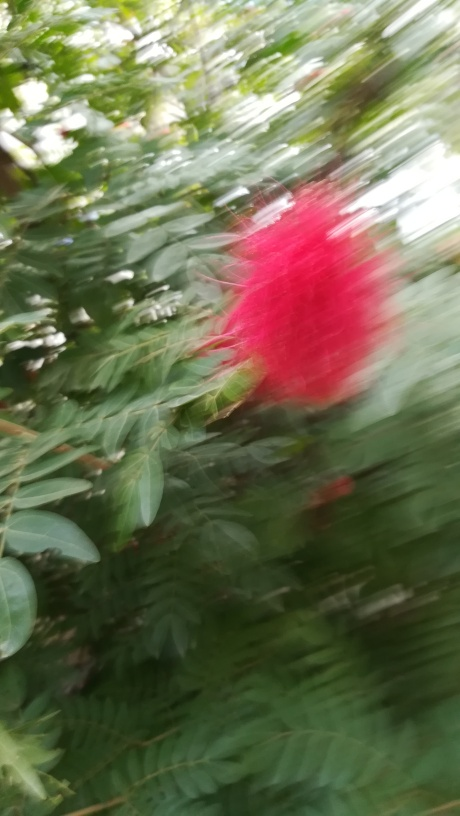What is the main subject of this image? The main subject seems to be a plant with prominent red flowers, likely in a garden or natural environment, but the details are not clear due to the motion blur. 